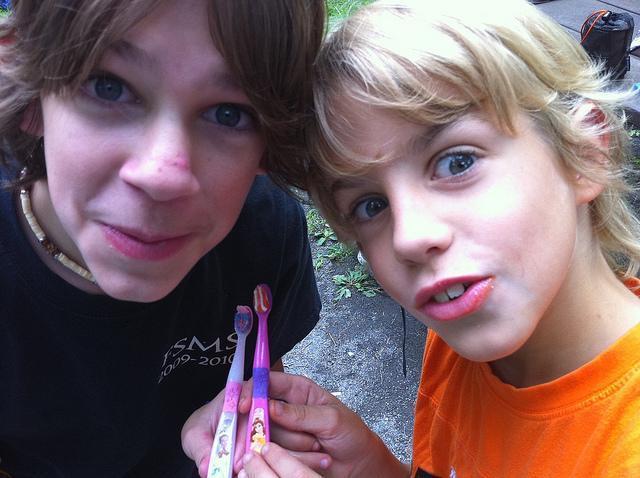How many toothbrushes are visible?
Give a very brief answer. 2. How many people are there?
Give a very brief answer. 2. How many wheels on the skateboard are in the air?
Give a very brief answer. 0. 